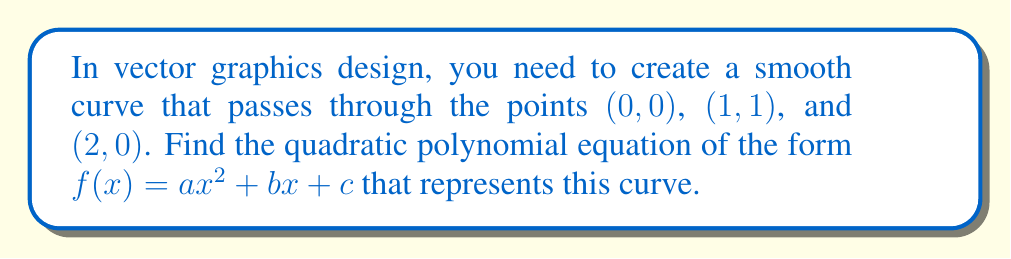What is the answer to this math problem? Let's approach this step-by-step:

1) We know the curve passes through three points: (0, 0), (1, 1), and (2, 0).

2) Let's substitute these points into the general form of a quadratic equation:
   $f(x) = ax^2 + bx + c$

   For (0, 0): $0 = a(0)^2 + b(0) + c$, so $c = 0$

   For (1, 1): $1 = a(1)^2 + b(1) + 0$, so $1 = a + b$

   For (2, 0): $0 = a(2)^2 + b(2) + 0$, so $0 = 4a + 2b$

3) From the last equation: $4a + 2b = 0$
   Divide by 2: $2a + b = 0$
   Rearrange: $b = -2a$

4) Substitute this into $1 = a + b$:
   $1 = a + (-2a) = -a$

5) Solve for $a$:
   $a = -1$

6) Now we can find $b$:
   $b = -2a = -2(-1) = 2$

7) Remember, we found earlier that $c = 0$

Therefore, the quadratic equation is:
$f(x) = -x^2 + 2x$
Answer: $f(x) = -x^2 + 2x$ 